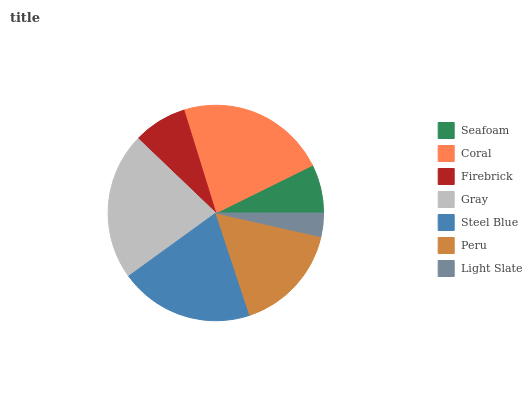Is Light Slate the minimum?
Answer yes or no. Yes. Is Coral the maximum?
Answer yes or no. Yes. Is Firebrick the minimum?
Answer yes or no. No. Is Firebrick the maximum?
Answer yes or no. No. Is Coral greater than Firebrick?
Answer yes or no. Yes. Is Firebrick less than Coral?
Answer yes or no. Yes. Is Firebrick greater than Coral?
Answer yes or no. No. Is Coral less than Firebrick?
Answer yes or no. No. Is Peru the high median?
Answer yes or no. Yes. Is Peru the low median?
Answer yes or no. Yes. Is Steel Blue the high median?
Answer yes or no. No. Is Gray the low median?
Answer yes or no. No. 